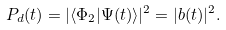Convert formula to latex. <formula><loc_0><loc_0><loc_500><loc_500>P _ { d } ( t ) = | \langle \Phi _ { 2 } | \Psi ( t ) \rangle | ^ { 2 } = | b ( t ) | ^ { 2 } .</formula> 